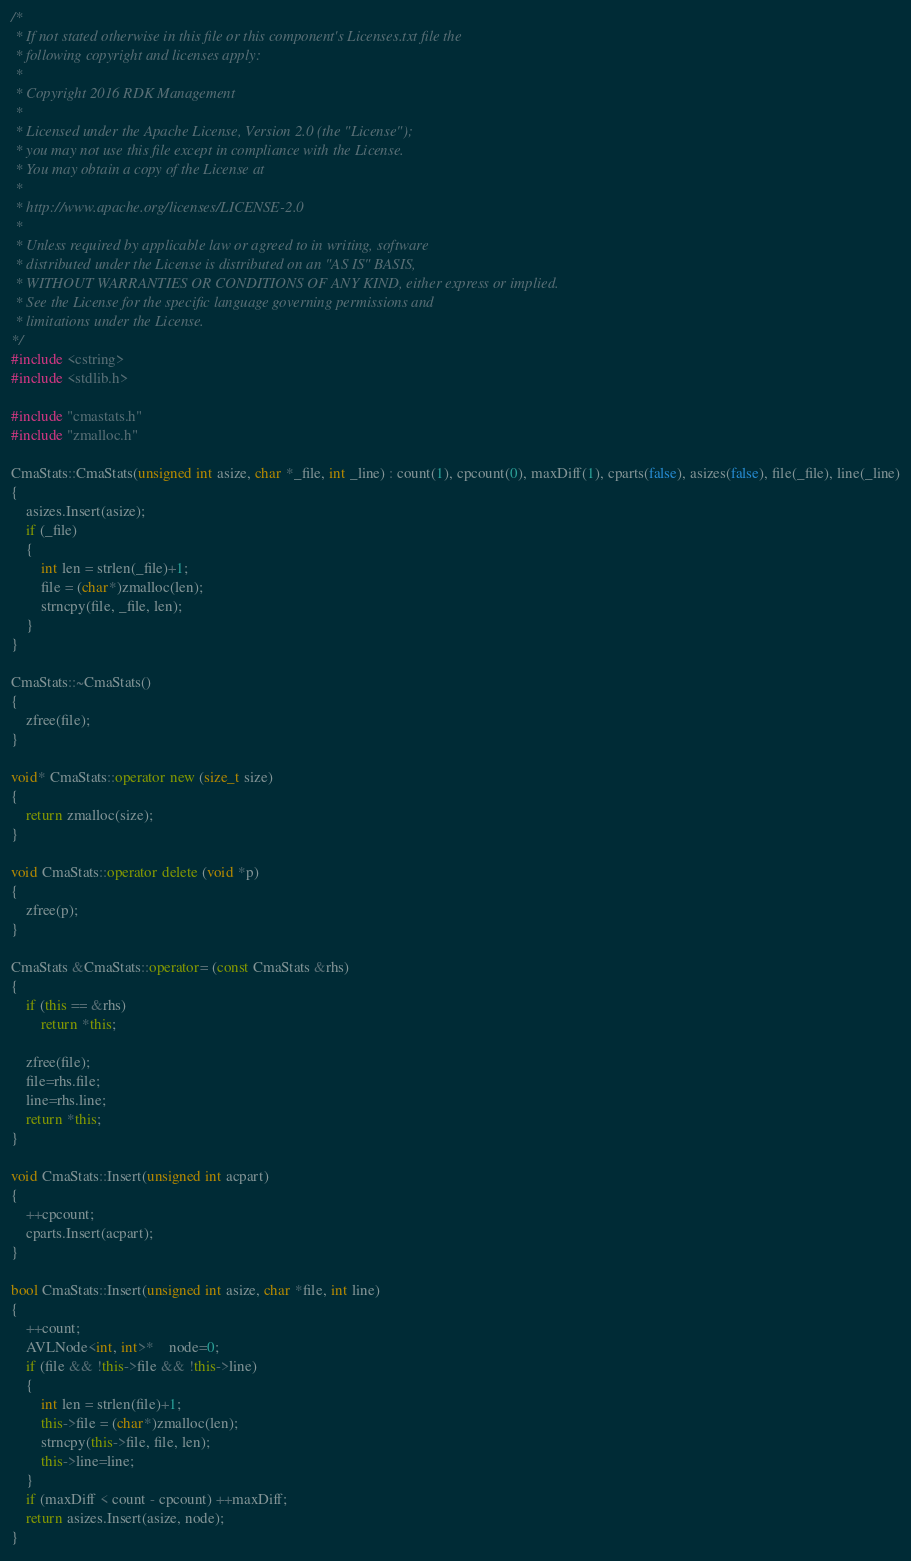Convert code to text. <code><loc_0><loc_0><loc_500><loc_500><_C++_>/*
 * If not stated otherwise in this file or this component's Licenses.txt file the
 * following copyright and licenses apply:
 *
 * Copyright 2016 RDK Management
 *
 * Licensed under the Apache License, Version 2.0 (the "License");
 * you may not use this file except in compliance with the License.
 * You may obtain a copy of the License at
 *
 * http://www.apache.org/licenses/LICENSE-2.0
 *
 * Unless required by applicable law or agreed to in writing, software
 * distributed under the License is distributed on an "AS IS" BASIS,
 * WITHOUT WARRANTIES OR CONDITIONS OF ANY KIND, either express or implied.
 * See the License for the specific language governing permissions and
 * limitations under the License.
*/
#include <cstring>
#include <stdlib.h>

#include "cmastats.h"
#include "zmalloc.h"

CmaStats::CmaStats(unsigned int asize, char *_file, int _line) : count(1), cpcount(0), maxDiff(1), cparts(false), asizes(false), file(_file), line(_line)
{
	asizes.Insert(asize);
	if (_file)
	{
		int len = strlen(_file)+1;
		file = (char*)zmalloc(len);
		strncpy(file, _file, len);
	}
}

CmaStats::~CmaStats()
{
	zfree(file);
}

void* CmaStats::operator new (size_t size)
{
	return zmalloc(size);
}

void CmaStats::operator delete (void *p)
{
	zfree(p);
}

CmaStats &CmaStats::operator= (const CmaStats &rhs)
{
	if (this == &rhs)
		return *this;

	zfree(file);
	file=rhs.file;
	line=rhs.line;
	return *this;
}

void CmaStats::Insert(unsigned int acpart)
{
	++cpcount;
	cparts.Insert(acpart);
}

bool CmaStats::Insert(unsigned int asize, char *file, int line)
{
	++count;
	AVLNode<int, int>*	node=0;
	if (file && !this->file && !this->line)
	{
		int len = strlen(file)+1;
		this->file = (char*)zmalloc(len);
		strncpy(this->file, file, len);
		this->line=line;
	}
	if (maxDiff < count - cpcount) ++maxDiff;
	return asizes.Insert(asize, node);
}
</code> 